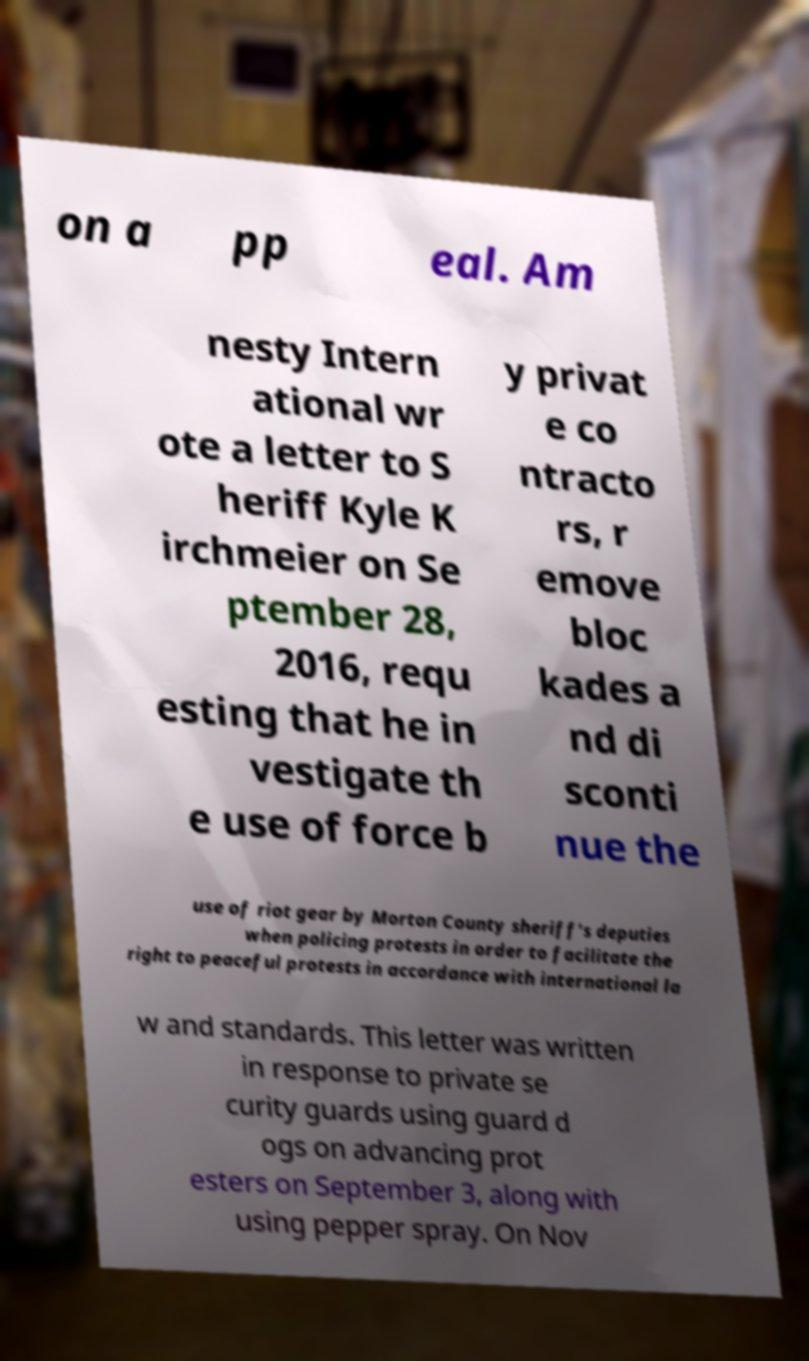Can you accurately transcribe the text from the provided image for me? on a pp eal. Am nesty Intern ational wr ote a letter to S heriff Kyle K irchmeier on Se ptember 28, 2016, requ esting that he in vestigate th e use of force b y privat e co ntracto rs, r emove bloc kades a nd di sconti nue the use of riot gear by Morton County sheriff's deputies when policing protests in order to facilitate the right to peaceful protests in accordance with international la w and standards. This letter was written in response to private se curity guards using guard d ogs on advancing prot esters on September 3, along with using pepper spray. On Nov 